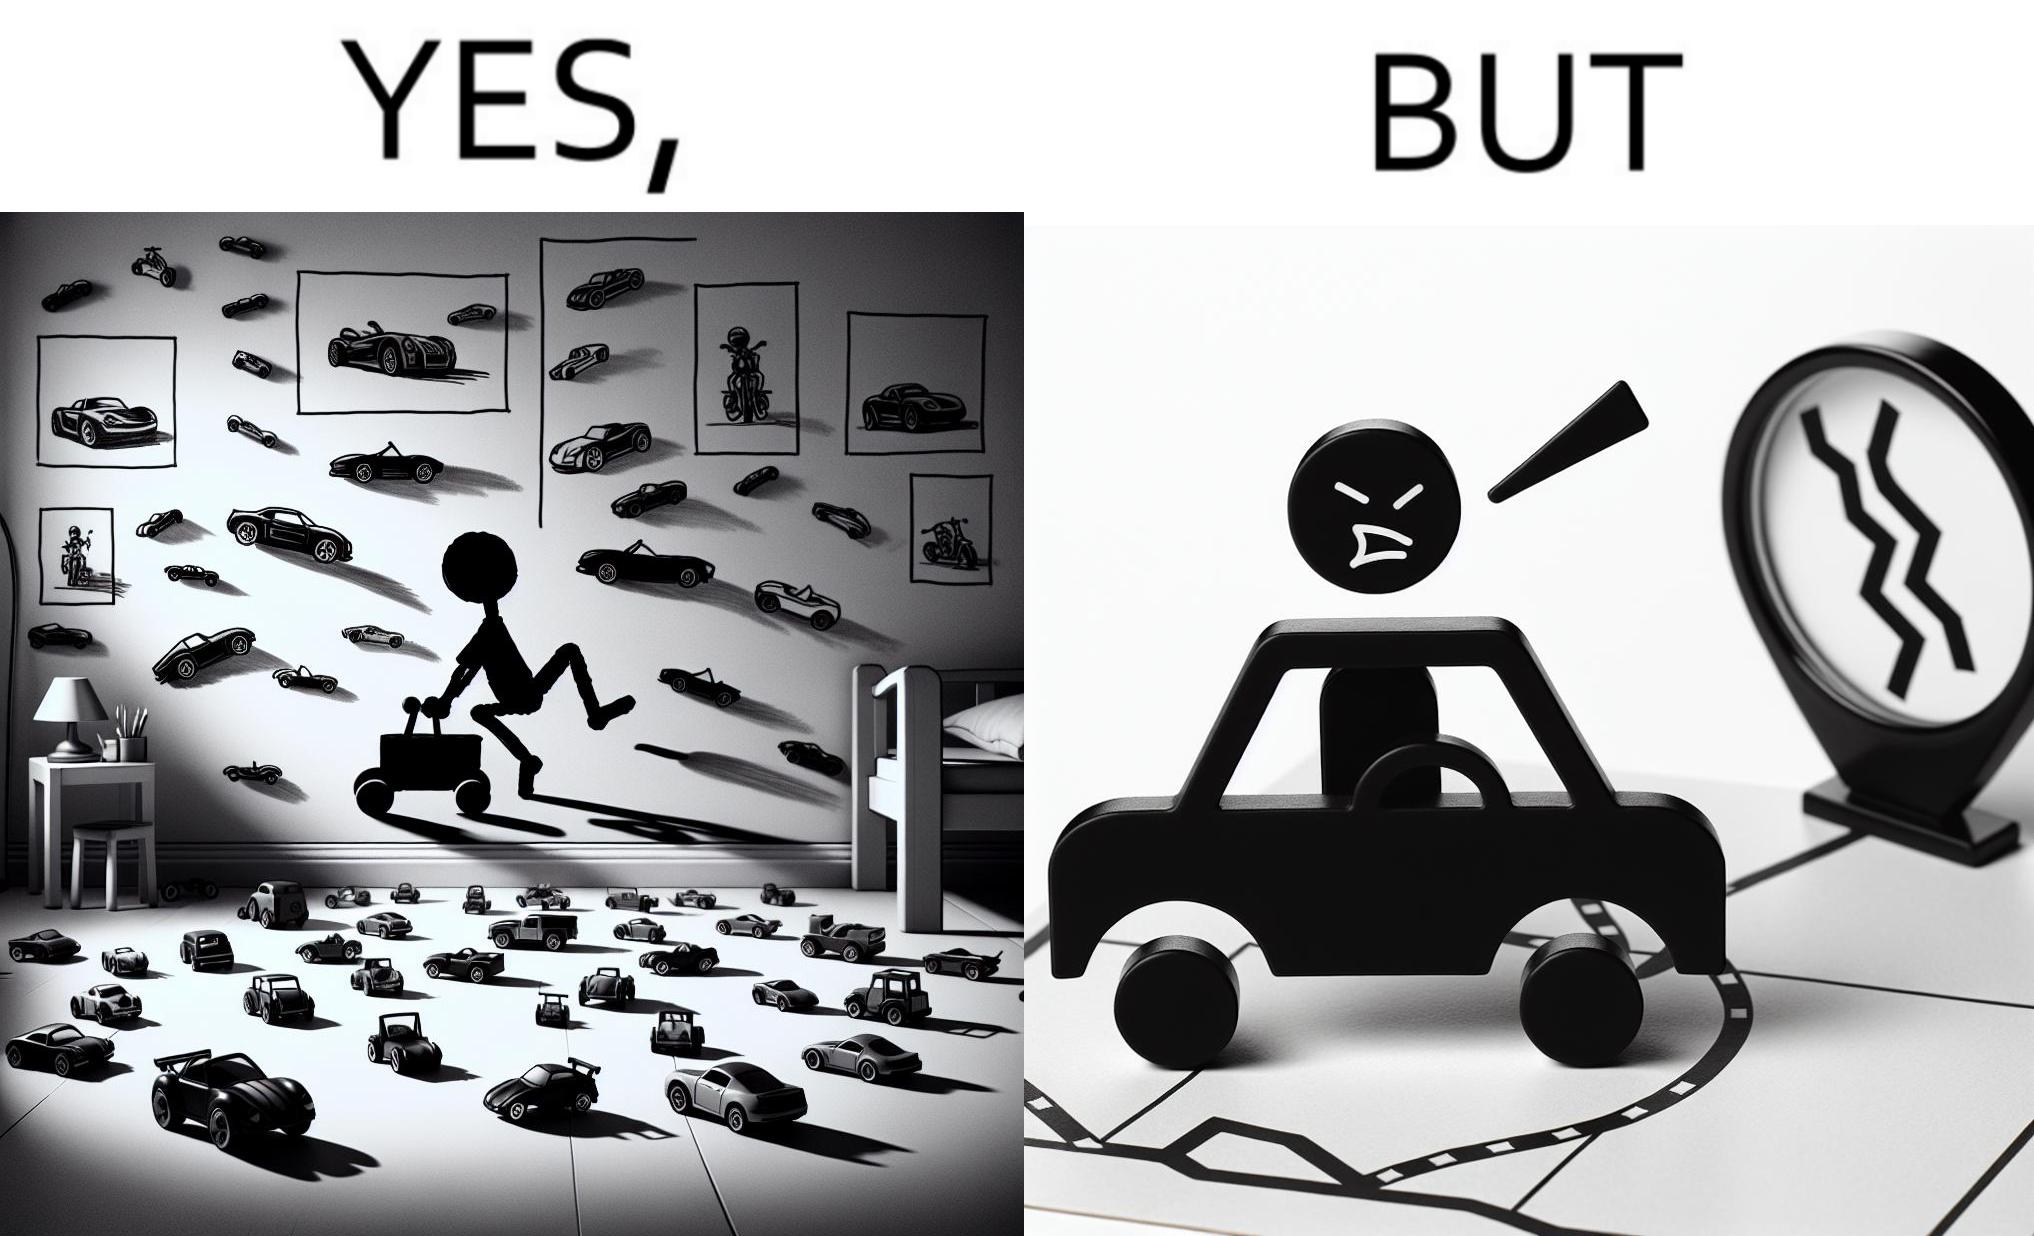Is there satirical content in this image? Yes, this image is satirical. 